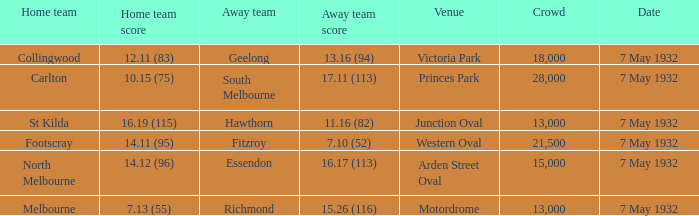What is the home team for victoria park? Collingwood. 